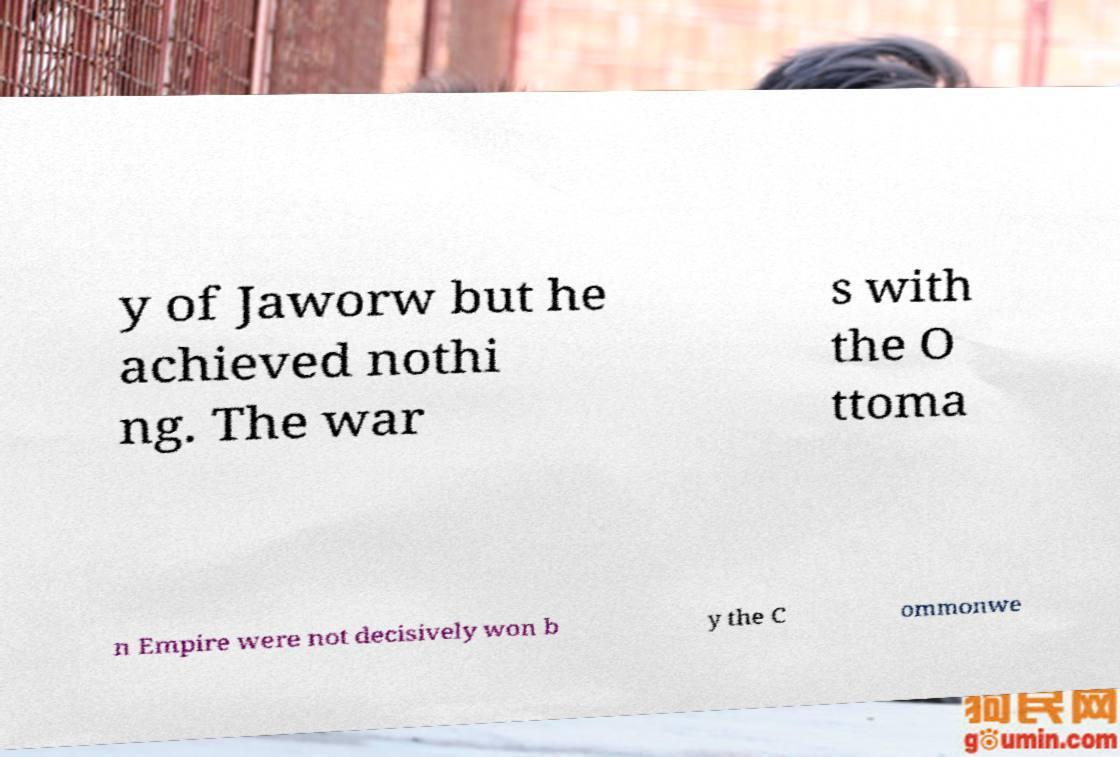Please identify and transcribe the text found in this image. y of Jaworw but he achieved nothi ng. The war s with the O ttoma n Empire were not decisively won b y the C ommonwe 